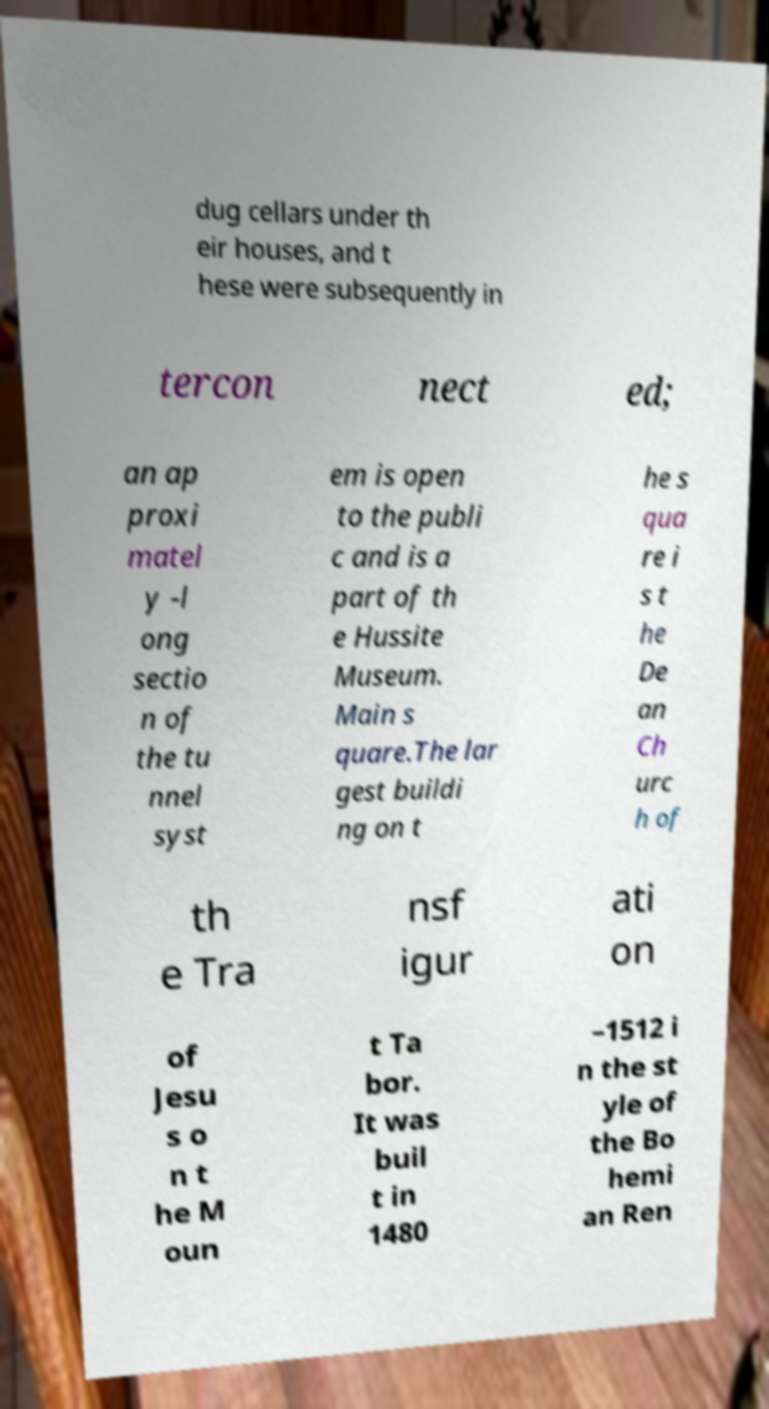What messages or text are displayed in this image? I need them in a readable, typed format. dug cellars under th eir houses, and t hese were subsequently in tercon nect ed; an ap proxi matel y -l ong sectio n of the tu nnel syst em is open to the publi c and is a part of th e Hussite Museum. Main s quare.The lar gest buildi ng on t he s qua re i s t he De an Ch urc h of th e Tra nsf igur ati on of Jesu s o n t he M oun t Ta bor. It was buil t in 1480 –1512 i n the st yle of the Bo hemi an Ren 